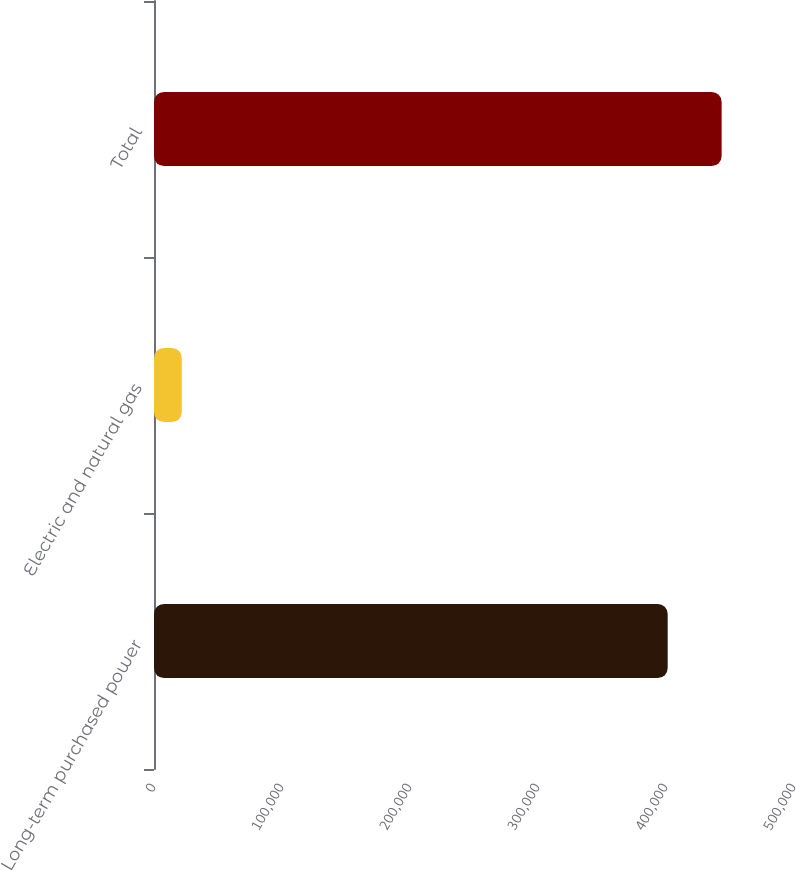<chart> <loc_0><loc_0><loc_500><loc_500><bar_chart><fcel>Long-term purchased power<fcel>Electric and natural gas<fcel>Total<nl><fcel>401313<fcel>21694<fcel>443467<nl></chart> 